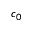<formula> <loc_0><loc_0><loc_500><loc_500>c _ { 0 }</formula> 